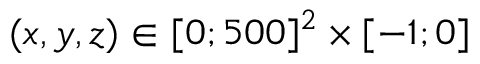<formula> <loc_0><loc_0><loc_500><loc_500>( x , y , z ) \in [ 0 ; 5 0 0 ] ^ { 2 } \times [ - 1 ; 0 ]</formula> 